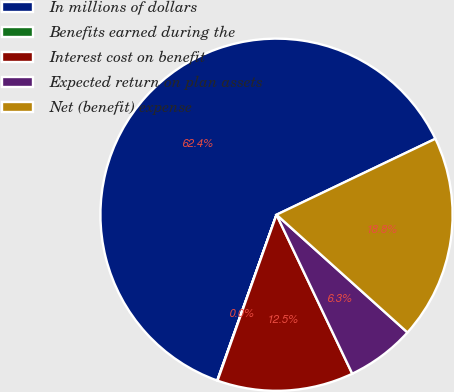<chart> <loc_0><loc_0><loc_500><loc_500><pie_chart><fcel>In millions of dollars<fcel>Benefits earned during the<fcel>Interest cost on benefit<fcel>Expected return on plan assets<fcel>Net (benefit) expense<nl><fcel>62.43%<fcel>0.03%<fcel>12.51%<fcel>6.27%<fcel>18.75%<nl></chart> 